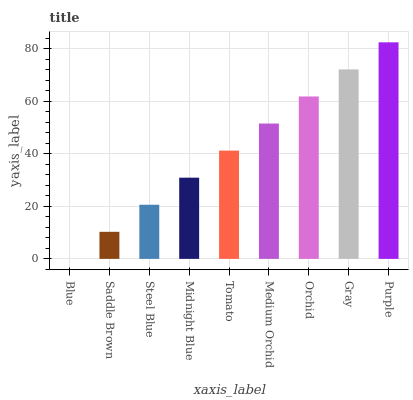Is Saddle Brown the minimum?
Answer yes or no. No. Is Saddle Brown the maximum?
Answer yes or no. No. Is Saddle Brown greater than Blue?
Answer yes or no. Yes. Is Blue less than Saddle Brown?
Answer yes or no. Yes. Is Blue greater than Saddle Brown?
Answer yes or no. No. Is Saddle Brown less than Blue?
Answer yes or no. No. Is Tomato the high median?
Answer yes or no. Yes. Is Tomato the low median?
Answer yes or no. Yes. Is Midnight Blue the high median?
Answer yes or no. No. Is Purple the low median?
Answer yes or no. No. 